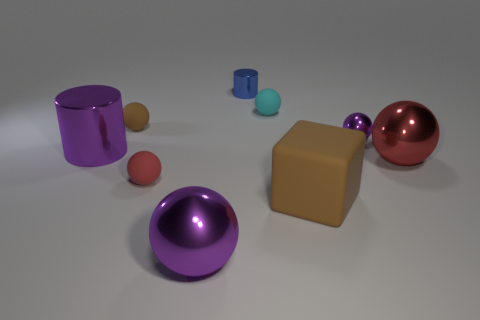Subtract 2 spheres. How many spheres are left? 4 Subtract all cyan spheres. How many spheres are left? 5 Subtract all red metallic spheres. How many spheres are left? 5 Subtract all green balls. Subtract all purple blocks. How many balls are left? 6 Add 1 small rubber balls. How many objects exist? 10 Subtract all spheres. How many objects are left? 3 Add 7 large brown matte things. How many large brown matte things are left? 8 Add 6 blocks. How many blocks exist? 7 Subtract 1 cyan balls. How many objects are left? 8 Subtract all cyan shiny objects. Subtract all tiny blue things. How many objects are left? 8 